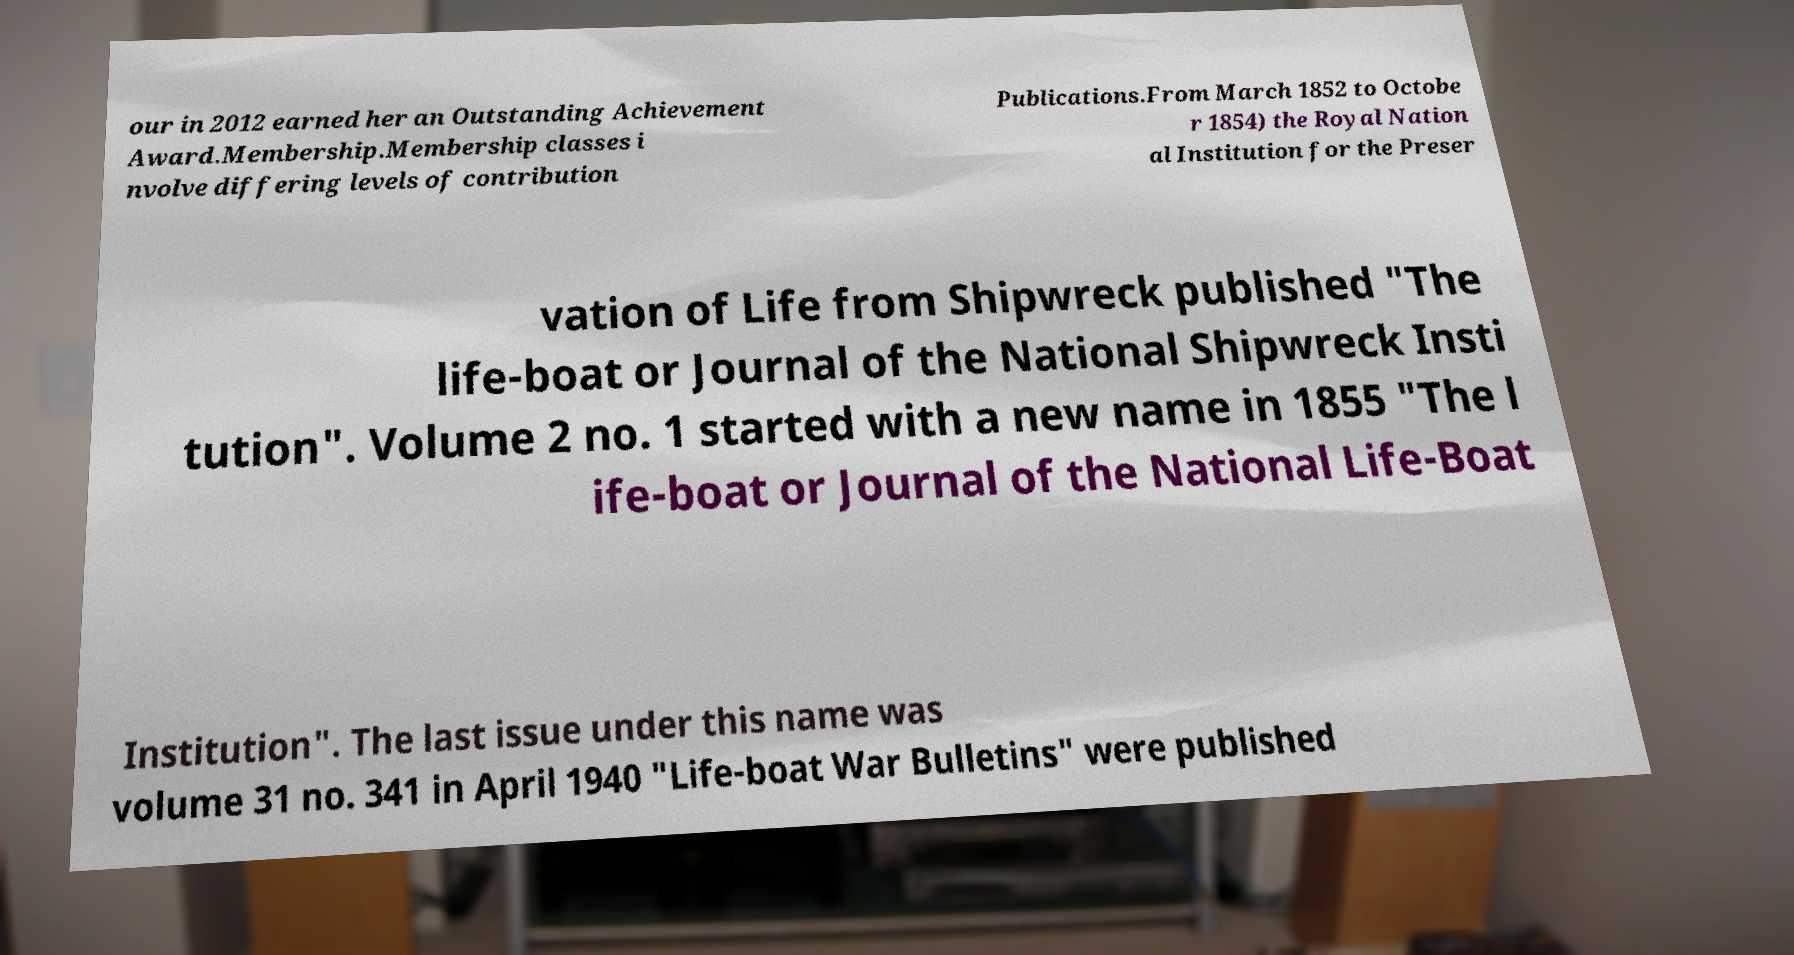Can you accurately transcribe the text from the provided image for me? our in 2012 earned her an Outstanding Achievement Award.Membership.Membership classes i nvolve differing levels of contribution Publications.From March 1852 to Octobe r 1854) the Royal Nation al Institution for the Preser vation of Life from Shipwreck published "The life-boat or Journal of the National Shipwreck Insti tution". Volume 2 no. 1 started with a new name in 1855 "The l ife-boat or Journal of the National Life-Boat Institution". The last issue under this name was volume 31 no. 341 in April 1940 "Life-boat War Bulletins" were published 